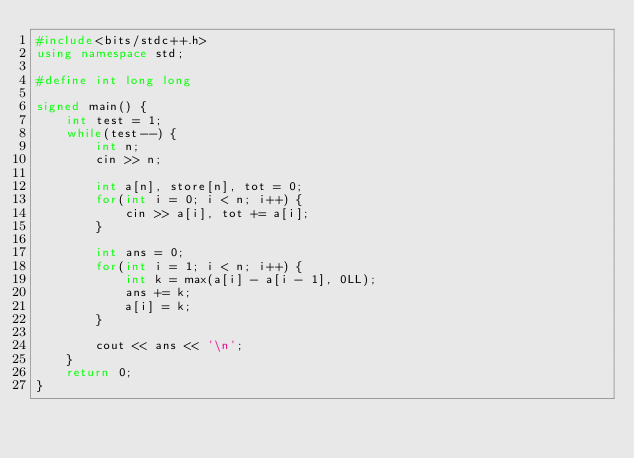Convert code to text. <code><loc_0><loc_0><loc_500><loc_500><_C++_>#include<bits/stdc++.h>
using namespace std;

#define int long long 

signed main() {
	int test = 1;
  	while(test--) {
    	int n;
      	cin >> n;
      
      	int a[n], store[n], tot = 0;
      	for(int i = 0; i < n; i++) {
          	cin >> a[i], tot += a[i];
        }

        int ans = 0;
        for(int i = 1; i < n; i++) {
        	int k = max(a[i] - a[i - 1], 0LL);
        	ans += k;
        	a[i] = k;
        }

        cout << ans << '\n';
    }
  	return 0;
}</code> 